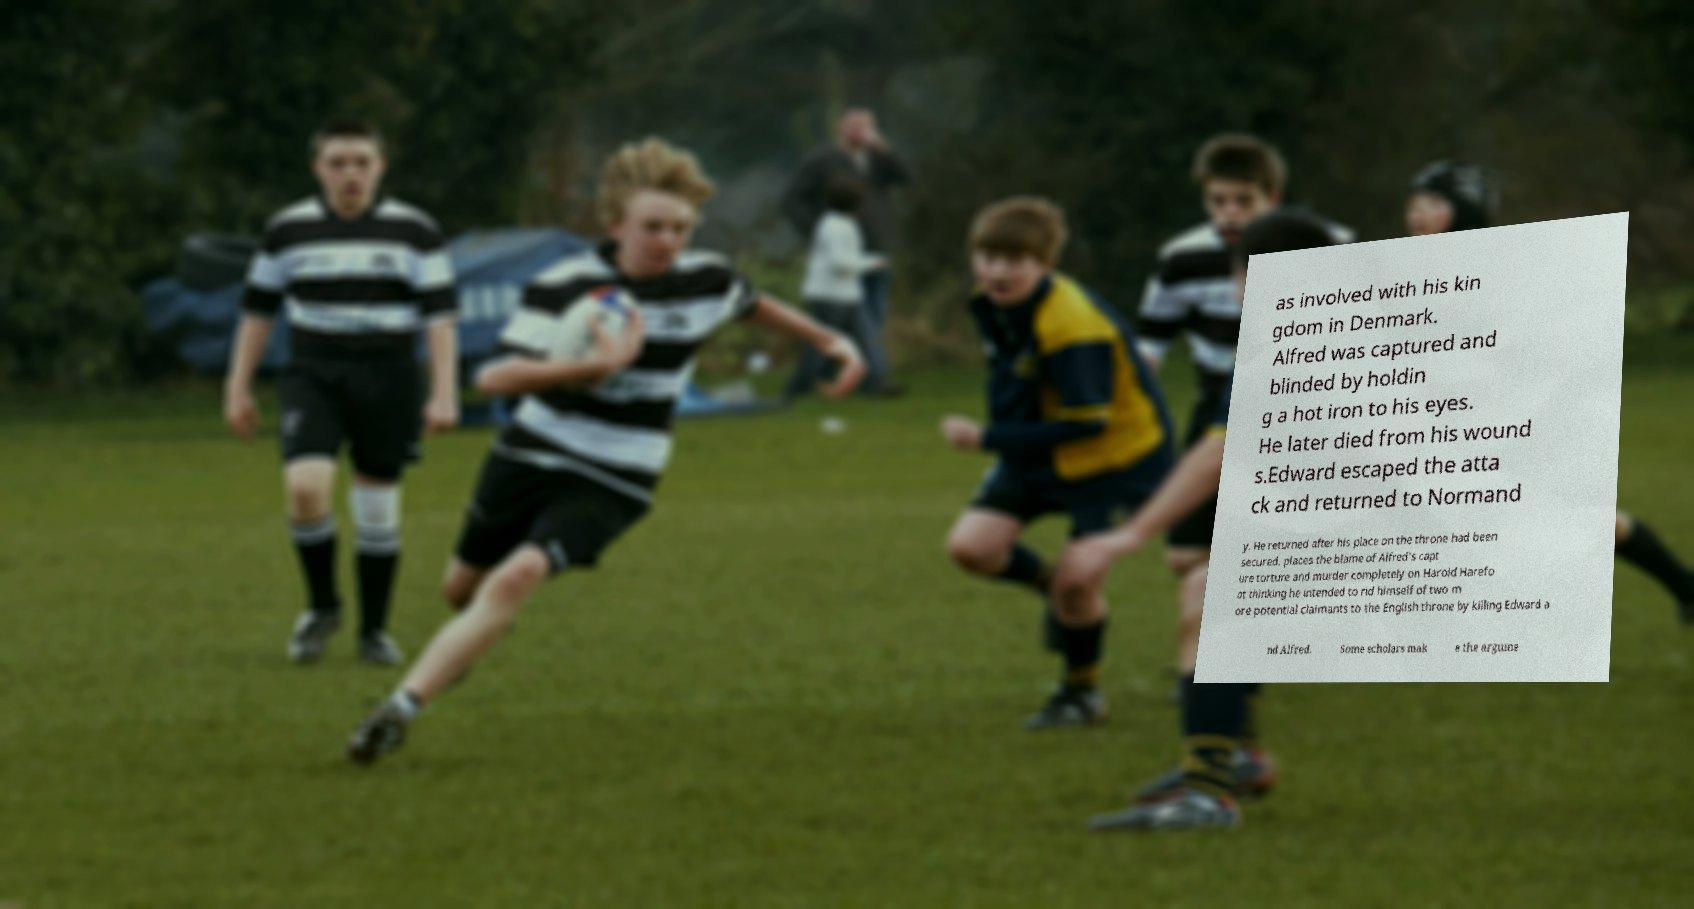Please read and relay the text visible in this image. What does it say? as involved with his kin gdom in Denmark. Alfred was captured and blinded by holdin g a hot iron to his eyes. He later died from his wound s.Edward escaped the atta ck and returned to Normand y. He returned after his place on the throne had been secured. places the blame of Alfred's capt ure torture and murder completely on Harold Harefo ot thinking he intended to rid himself of two m ore potential claimants to the English throne by killing Edward a nd Alfred. Some scholars mak e the argume 